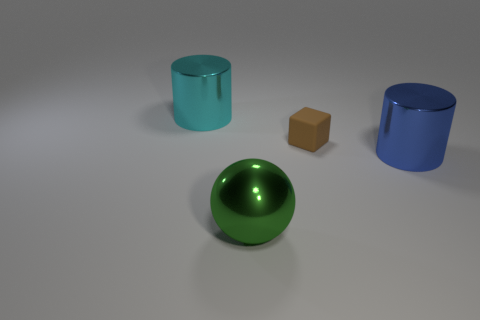What time of day does this scene appear to represent? The image seems to be captured in a controlled indoor setting with artificial lighting, making it difficult to determine an outdoor time of day from this scene. 